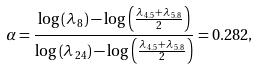<formula> <loc_0><loc_0><loc_500><loc_500>\alpha = \frac { \log \left ( \lambda _ { \, 8 } \right ) - \log \left ( \frac { \lambda _ { \, 4 . 5 } + \lambda _ { \, 5 . 8 } } { 2 } \right ) } { \log \left ( \lambda _ { \, 2 4 } \right ) - \log \left ( \frac { \lambda _ { \, 4 . 5 } + \lambda _ { \, 5 . 8 } } { 2 } \right ) } = 0 . 2 8 2 ,</formula> 